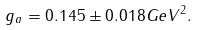Convert formula to latex. <formula><loc_0><loc_0><loc_500><loc_500>g _ { a } = 0 . 1 4 5 \pm 0 . 0 1 8 G e V ^ { 2 } .</formula> 